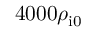Convert formula to latex. <formula><loc_0><loc_0><loc_500><loc_500>4 0 0 0 \rho _ { i 0 }</formula> 